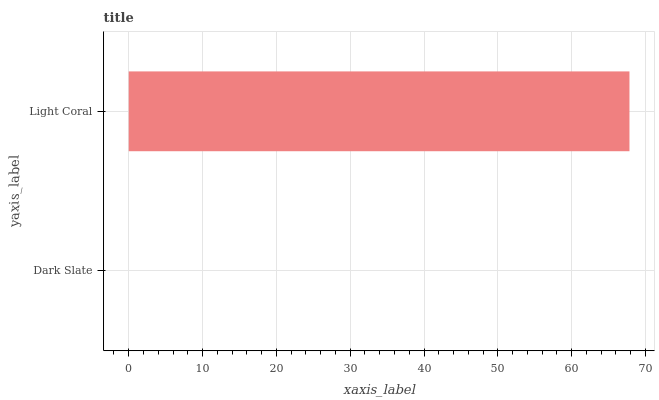Is Dark Slate the minimum?
Answer yes or no. Yes. Is Light Coral the maximum?
Answer yes or no. Yes. Is Light Coral the minimum?
Answer yes or no. No. Is Light Coral greater than Dark Slate?
Answer yes or no. Yes. Is Dark Slate less than Light Coral?
Answer yes or no. Yes. Is Dark Slate greater than Light Coral?
Answer yes or no. No. Is Light Coral less than Dark Slate?
Answer yes or no. No. Is Light Coral the high median?
Answer yes or no. Yes. Is Dark Slate the low median?
Answer yes or no. Yes. Is Dark Slate the high median?
Answer yes or no. No. Is Light Coral the low median?
Answer yes or no. No. 